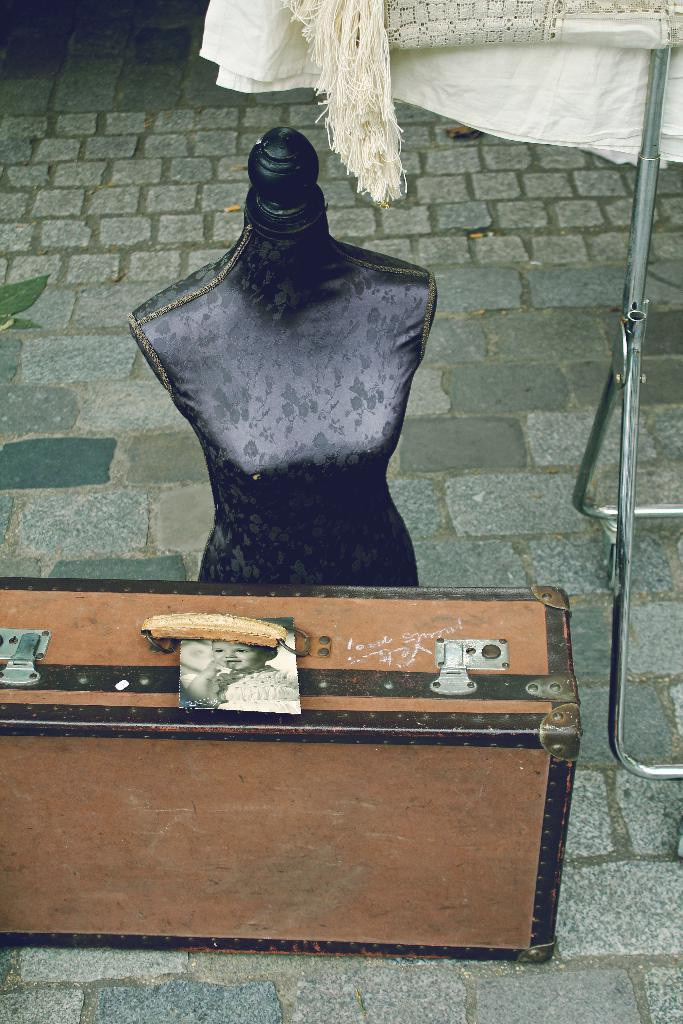What object can be seen in the image? There is a toy in the image. What color is the toy? The toy is black in color. Where is the toy located in the image? The toy is on the floor. What type of behavior can be observed from the squirrel in the image? There is no squirrel present in the image, so no behavior can be observed. How many apples are visible in the image? There are no apples present in the image. 